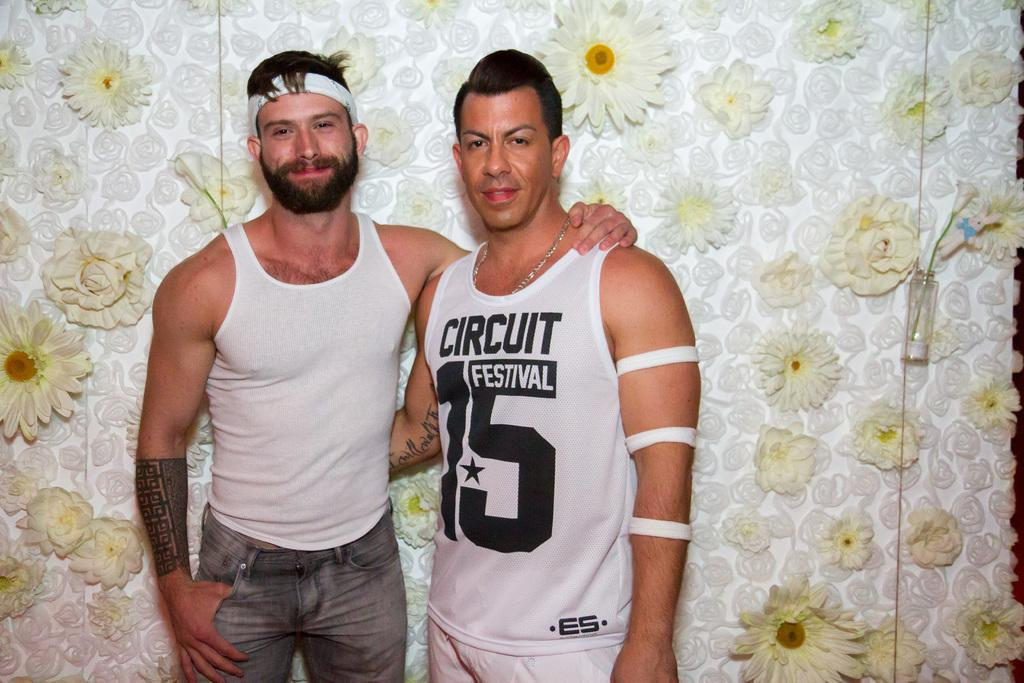<image>
Provide a brief description of the given image. Circuit Festival 15 reads the tank top of this gentleman. 